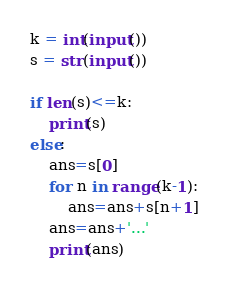<code> <loc_0><loc_0><loc_500><loc_500><_Python_>k = int(input())
s = str(input())

if len(s)<=k:
    print(s)
else:
    ans=s[0]
    for n in range(k-1):
        ans=ans+s[n+1]
    ans=ans+'...'
    print(ans)</code> 